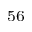Convert formula to latex. <formula><loc_0><loc_0><loc_500><loc_500>^ { 5 6 }</formula> 